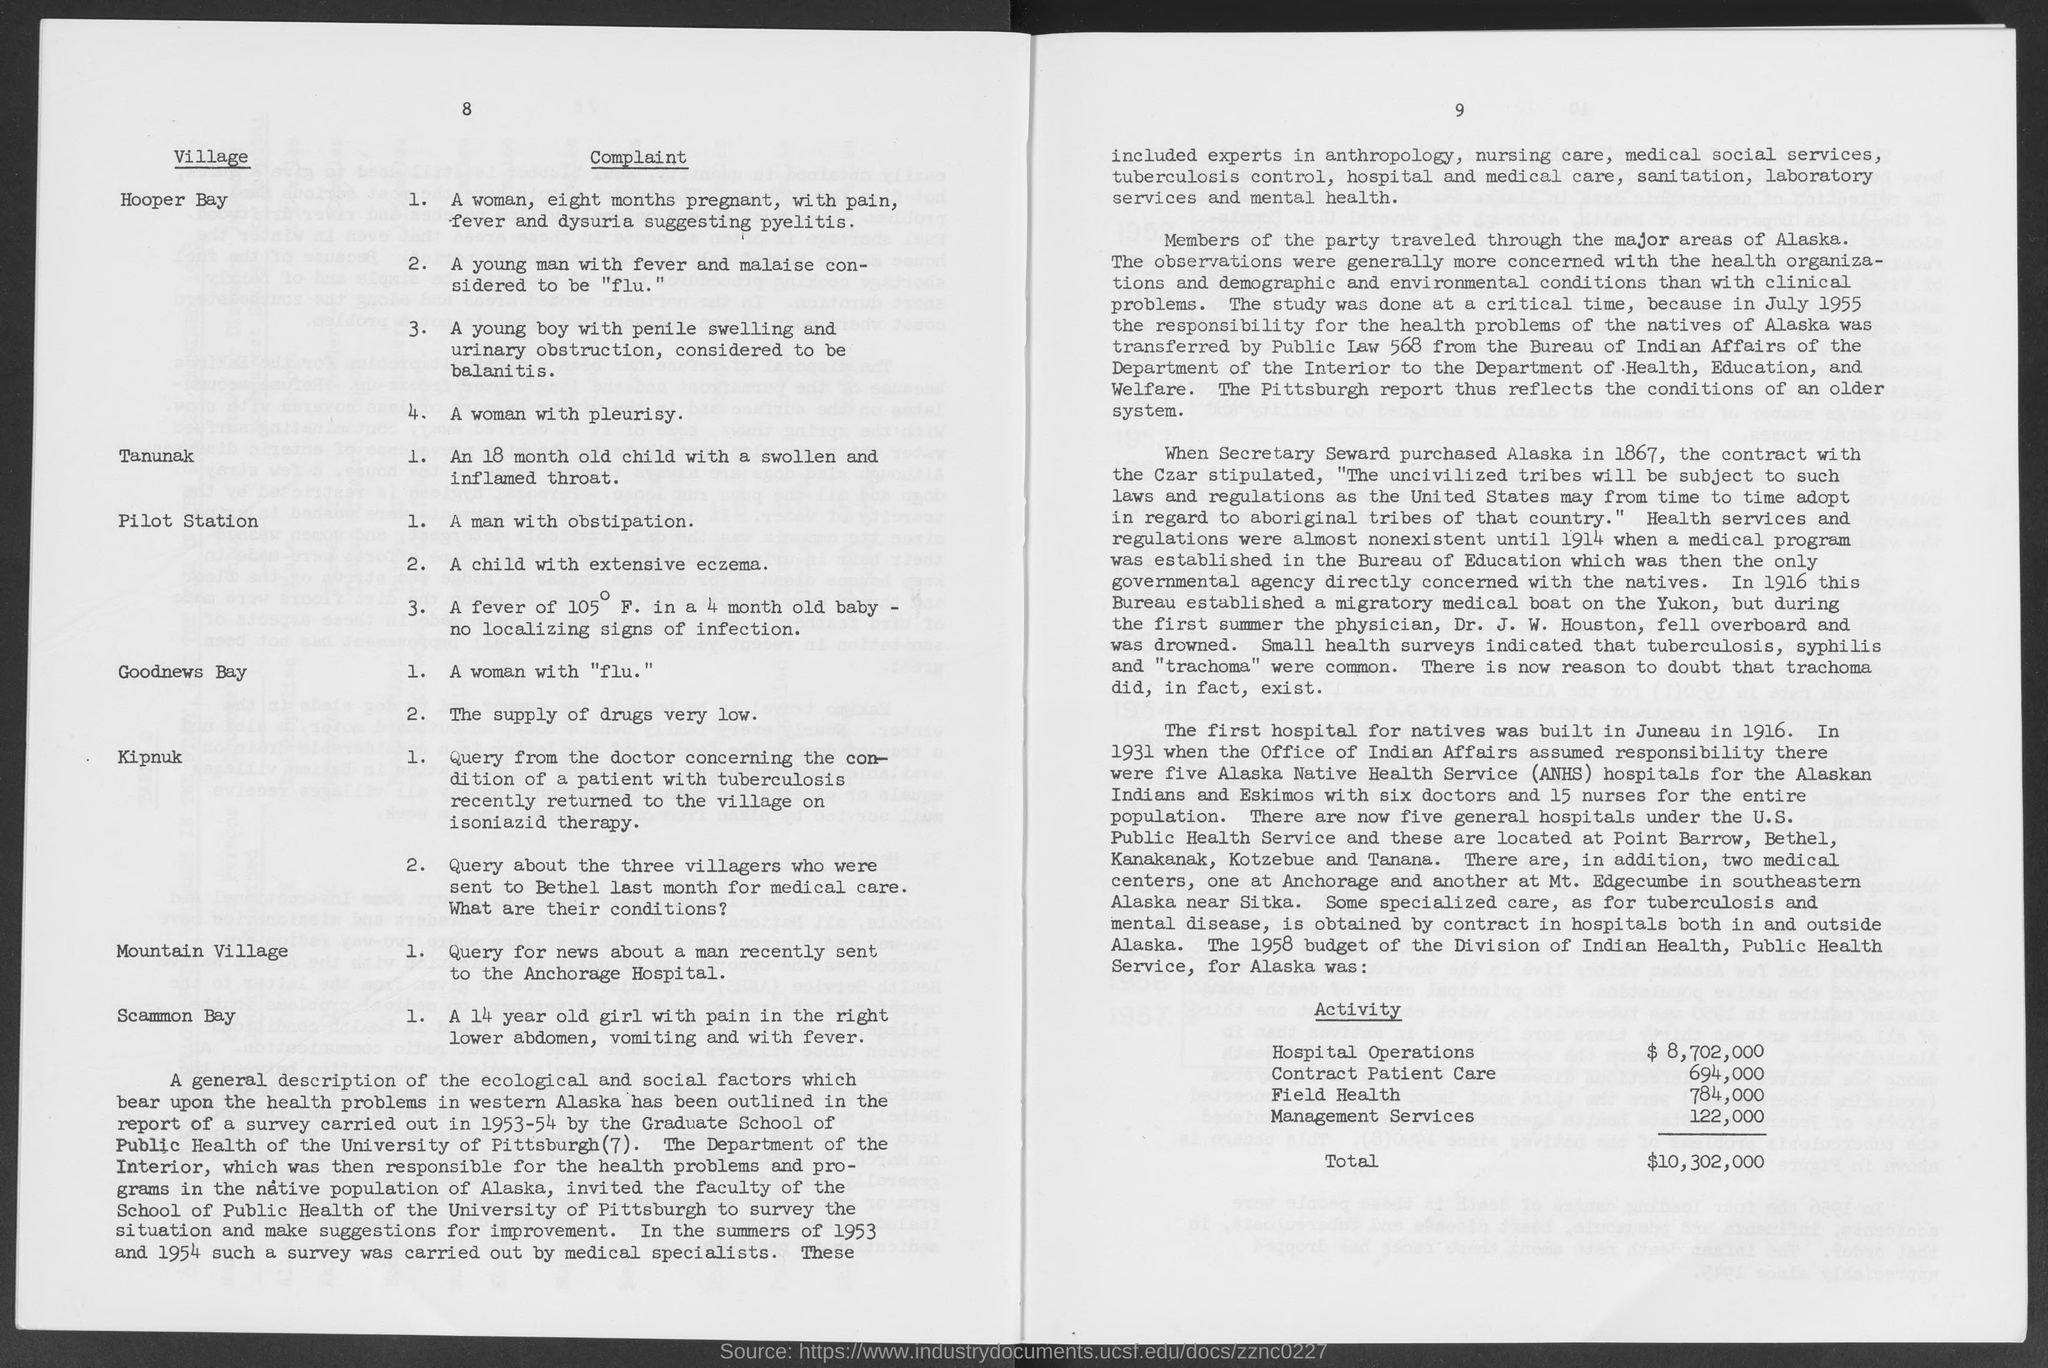What is the 1958 budget for Hospital operations activity for Alaska?
Give a very brief answer. $ 8,702,000. What is the 1958 budget for contract patient care activity for Alaska?
Your answer should be very brief. 694,000. What is the 1958 budget for management services activity for Alaska?
Give a very brief answer. 122,000. What is the 1958 budget for Field Health activity for Alaska?
Give a very brief answer. $784,000. What is the fullform of ANHS?
Ensure brevity in your answer.  Alaska Native Health Service. 